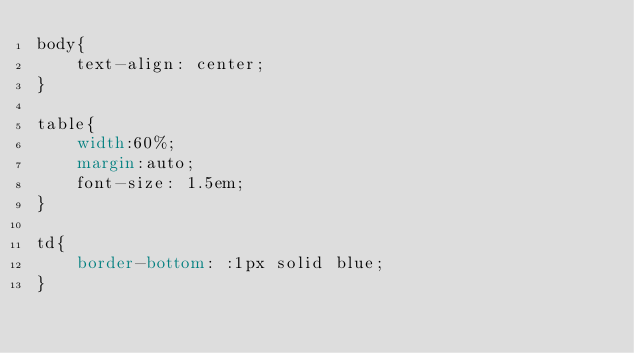Convert code to text. <code><loc_0><loc_0><loc_500><loc_500><_CSS_>body{
    text-align: center;
}

table{
    width:60%;
    margin:auto;
    font-size: 1.5em;
}

td{
    border-bottom: :1px solid blue;
}</code> 